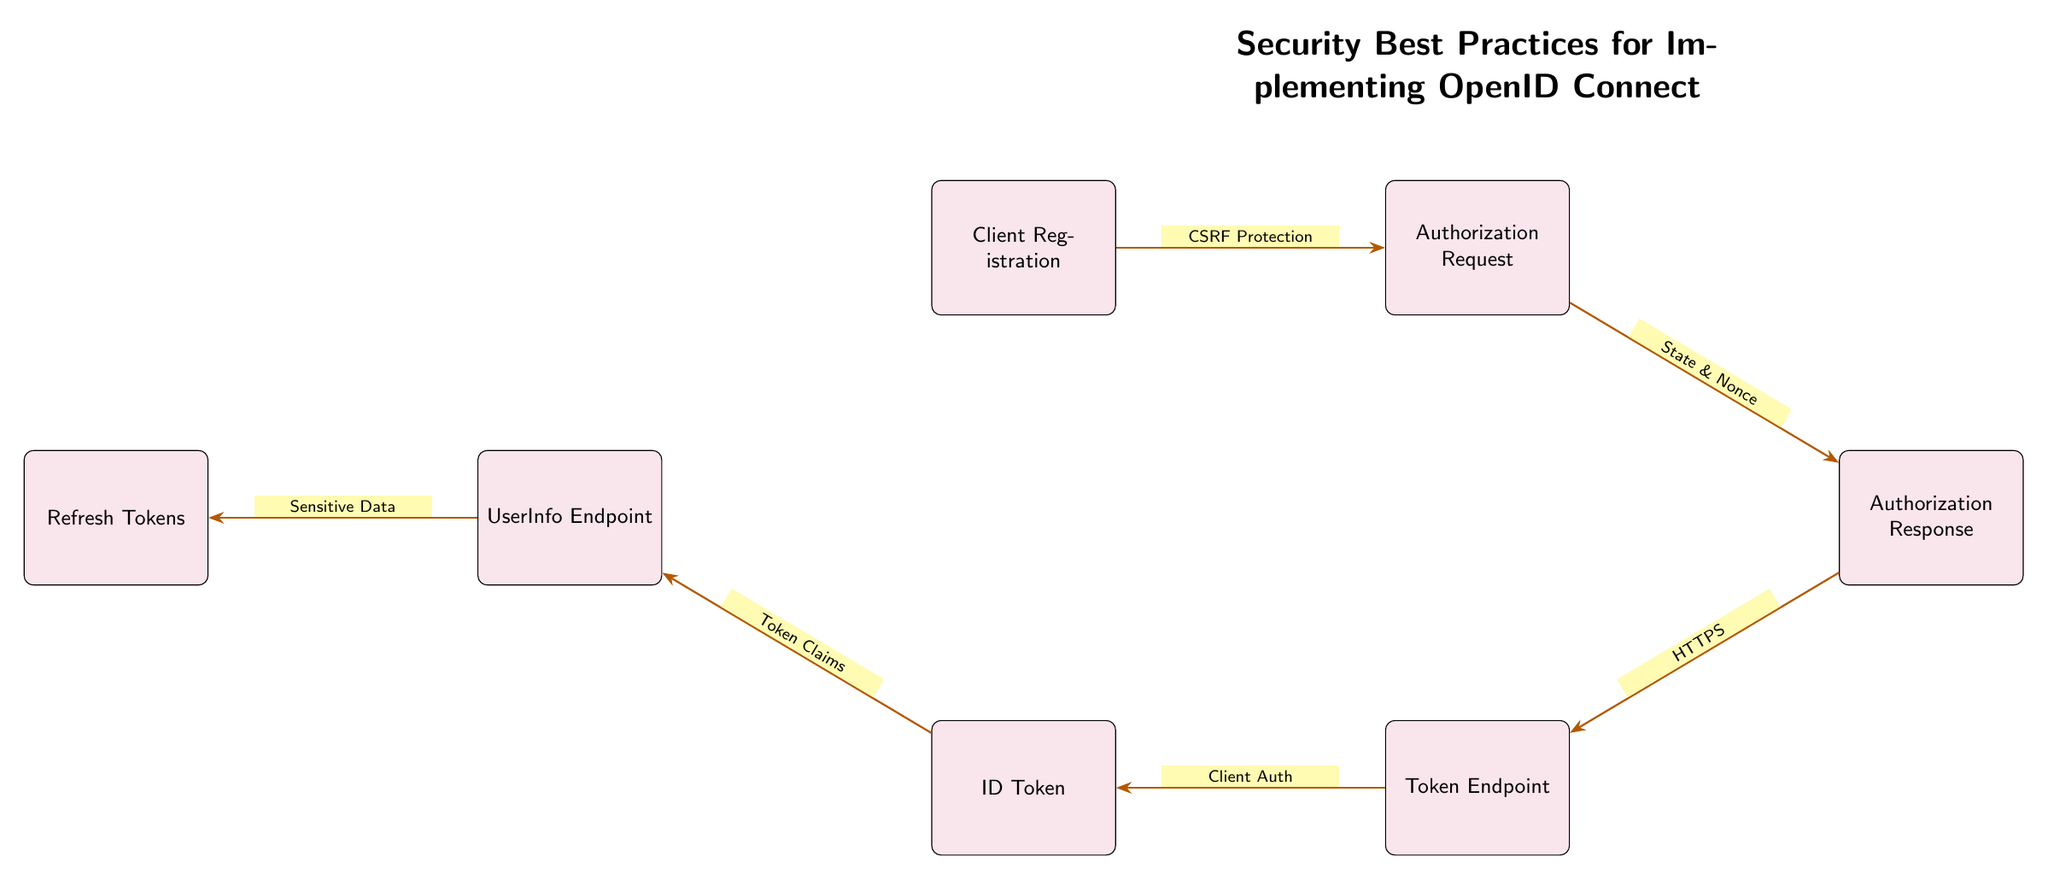What is the first step in the OIDC flow according to the diagram? The first step depicted in the diagram is "Client Registration," which is the initial process before any authorization requests are made.
Answer: Client Registration How many total nodes are present in the diagram? Counting all the boxes shown, there are a total of 7 nodes within the diagram, each representing a step or component in the OIDC flow.
Answer: 7 What protective measure is indicated between the Client Registration and Authorization Request nodes? The diagram specifies "CSRF Protection" as the protective measure to be implemented when transitioning from Client Registration to Authorization Request.
Answer: CSRF Protection What does the "Authorization Response" connect to in the OIDC flow? The "Authorization Response" connects to the next node, which is the "Token Endpoint," indicating a progression in the OIDC flow and the continued process of obtaining tokens.
Answer: Token Endpoint What type of data is indicated to be involved between "UserInfo Endpoint" and "Refresh Tokens"? The flow shows that "Sensitive Data" is the type of data being transferred or involved when moving from "UserInfo Endpoint" to "Refresh Tokens."
Answer: Sensitive Data What is the relationship between "ID Token" and "UserInfo Endpoint"? The diagram indicates a one-way connection where the "ID Token" leads to the "UserInfo Endpoint," suggesting that the ID Token is used to fetch additional user information securely.
Answer: UserInfo Endpoint How many protective measures are mentioned in the diagram? The diagram includes four protective measures, namely "CSRF Protection," "State & Nonce," "HTTPS," and "Client Auth," each associated with different components in the OIDC flow.
Answer: 4 What do "State & Nonce" refer to in this context? "State & Nonce" refer to protective measures employed during the transition from "Authorization Request" to "Authorization Response" to prevent potential replay and CSRF attacks.
Answer: Protective measures What is the final component in the OIDC flow represented in the diagram? The last node in the diagram indicates "Refresh Tokens," which represents the final stage of sustaining a user's authenticated session in the OIDC flow.
Answer: Refresh Tokens 